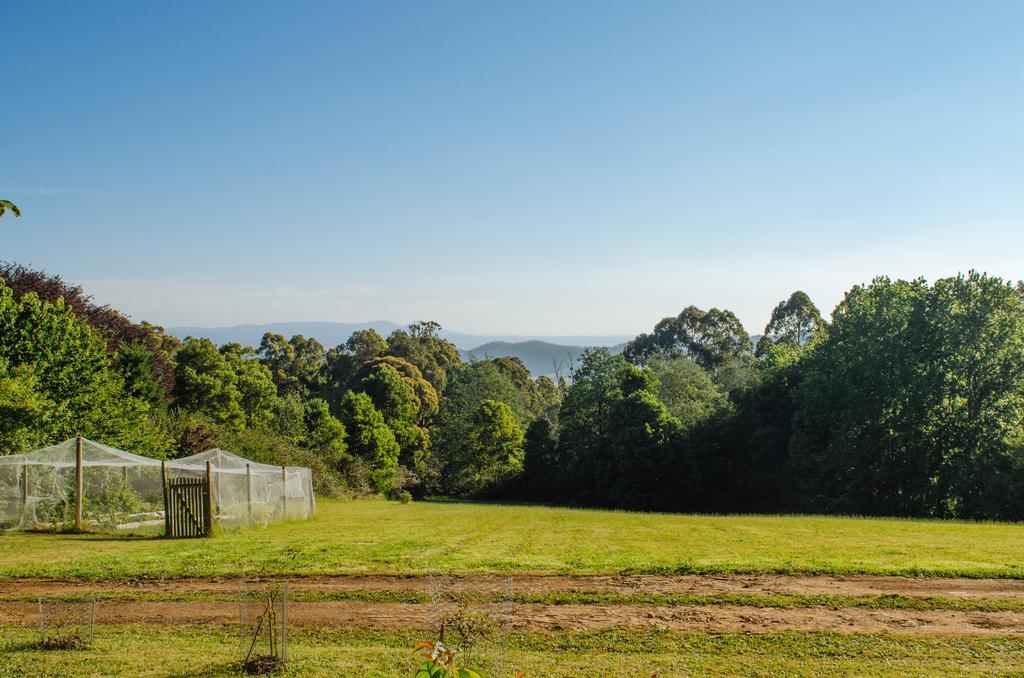Please provide a concise description of this image. In this image we can see a trees, plants, there are poles, net, there is a wooden railing, also we can see the mountains, and the sky. 